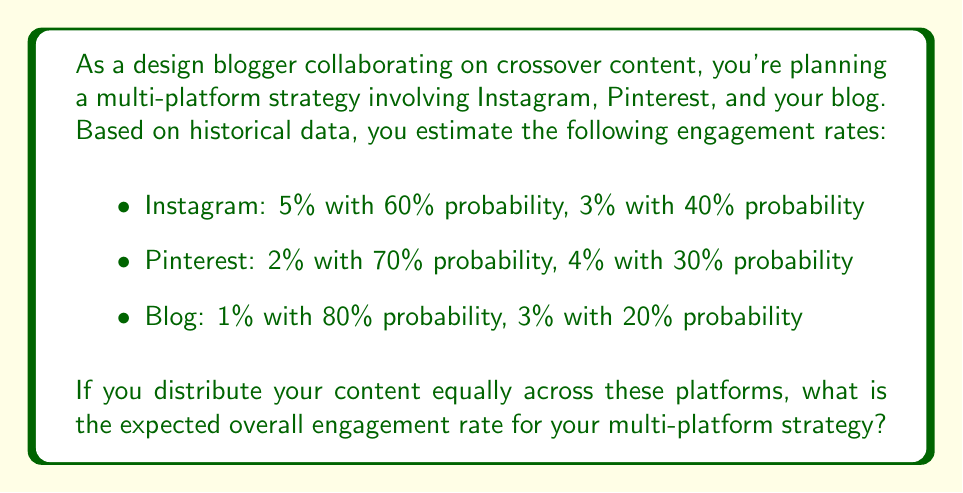Help me with this question. To solve this problem, we need to follow these steps:

1. Calculate the expected engagement rate for each platform:

   Instagram:
   $$E(Instagram) = 0.05 \cdot 0.60 + 0.03 \cdot 0.40 = 0.03 + 0.012 = 0.042 = 4.2\%$$

   Pinterest:
   $$E(Pinterest) = 0.02 \cdot 0.70 + 0.04 \cdot 0.30 = 0.014 + 0.012 = 0.026 = 2.6\%$$

   Blog:
   $$E(Blog) = 0.01 \cdot 0.80 + 0.03 \cdot 0.20 = 0.008 + 0.006 = 0.014 = 1.4\%$$

2. Since the content is distributed equally across the three platforms, we can calculate the overall expected engagement rate by taking the average of the individual expected rates:

   $$E(Overall) = \frac{E(Instagram) + E(Pinterest) + E(Blog)}{3}$$

3. Substitute the values:

   $$E(Overall) = \frac{0.042 + 0.026 + 0.014}{3} = \frac{0.082}{3} = 0.02733$$

4. Convert to percentage:

   $$0.02733 \cdot 100\% = 2.733\%$$

Thus, the expected overall engagement rate for the multi-platform strategy is approximately 2.733%.
Answer: 2.733% 